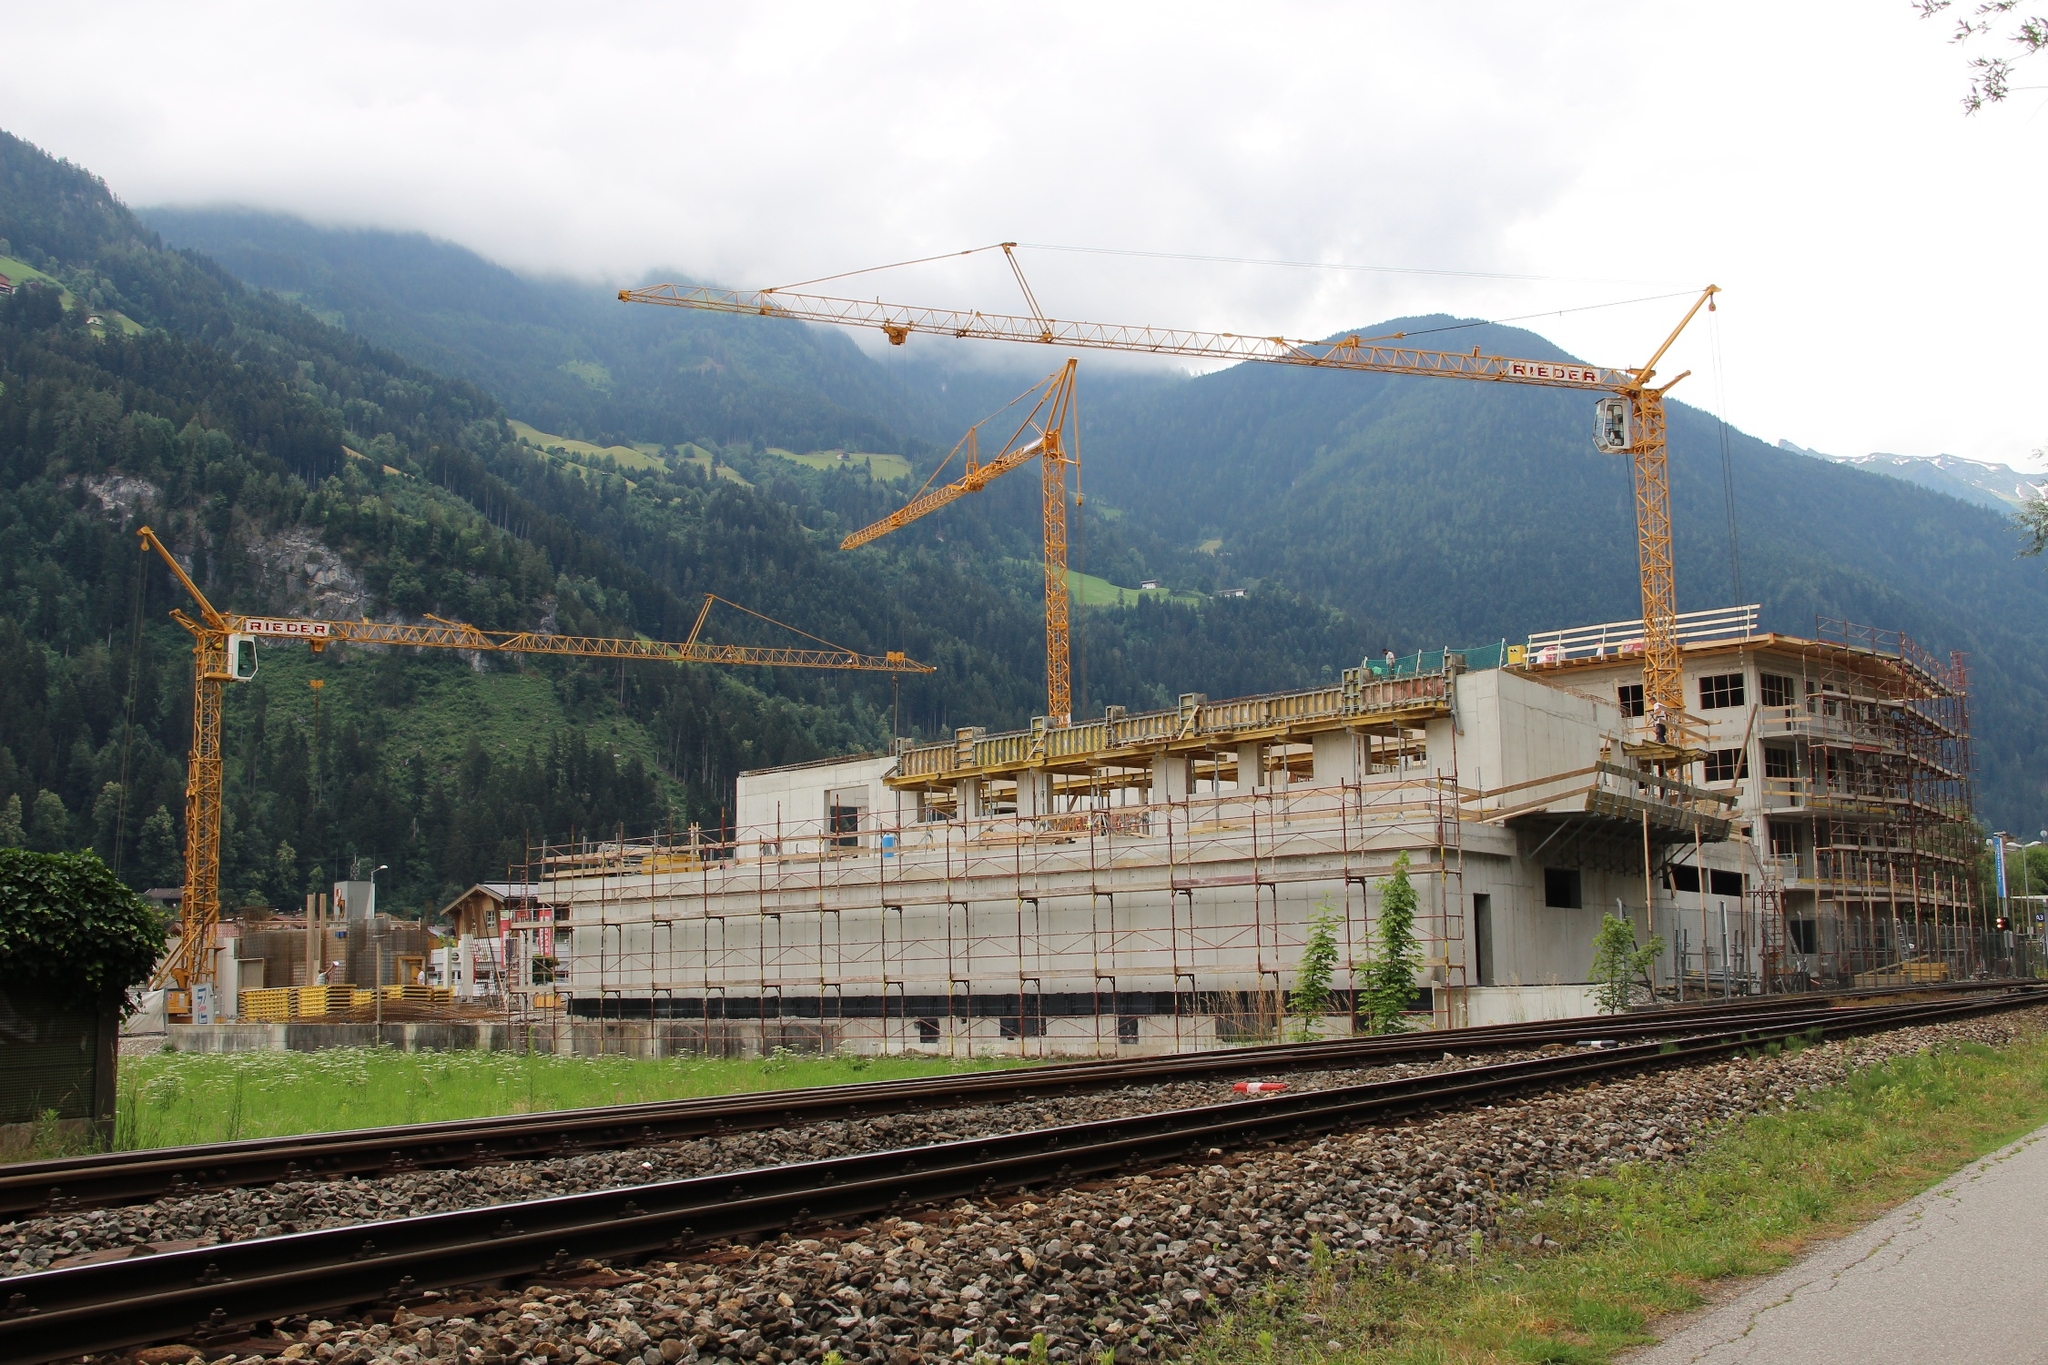Describe the following image. The image depicts a lively construction site set against a mountainous backdrop. Multiple cranes are prominently positioned, their long arms extended upwards, contributing to a hive of activity. The building structure under construction is enveloped in scaffolding, suggesting it is in the early phases of development. The vibrant green trees surrounding the site contrast with the industrial elements, bringing a touch of nature to the scene. A well-maintained train track runs in the foreground, its steel rails glistening under the daylight, adding another interesting layer to the composition. The distant perspective used in capturing this image provides an immersive view, showcasing the synergy between the ongoing construction and the breathtaking natural environment. Despite the presence of the landmark identifier 'sa_15064', no additional context on the exact location or type of construction is provided. 